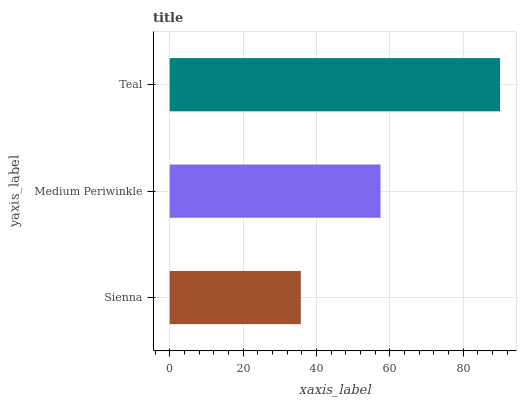Is Sienna the minimum?
Answer yes or no. Yes. Is Teal the maximum?
Answer yes or no. Yes. Is Medium Periwinkle the minimum?
Answer yes or no. No. Is Medium Periwinkle the maximum?
Answer yes or no. No. Is Medium Periwinkle greater than Sienna?
Answer yes or no. Yes. Is Sienna less than Medium Periwinkle?
Answer yes or no. Yes. Is Sienna greater than Medium Periwinkle?
Answer yes or no. No. Is Medium Periwinkle less than Sienna?
Answer yes or no. No. Is Medium Periwinkle the high median?
Answer yes or no. Yes. Is Medium Periwinkle the low median?
Answer yes or no. Yes. Is Sienna the high median?
Answer yes or no. No. Is Sienna the low median?
Answer yes or no. No. 